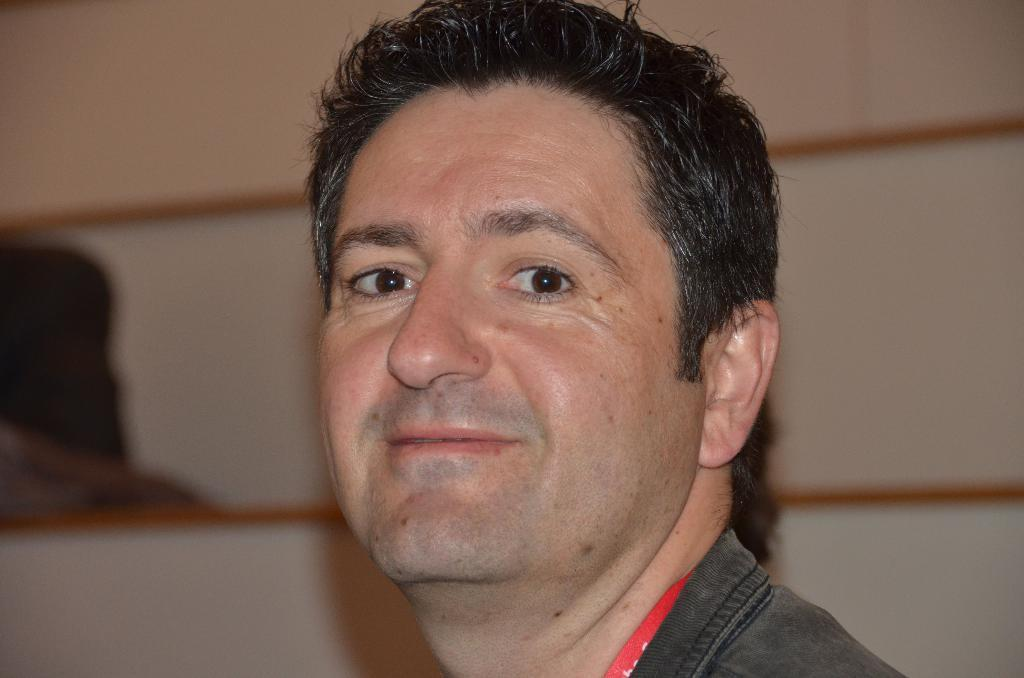Who or what is the main subject of the image? There is a person in the image. What can be seen of the person's face in the image? The person's face is visible in the image. How would you describe the background of the image? The background of the image is blurred. What type of book is the person holding in the image? There is no book present in the image; the person is the main subject. 